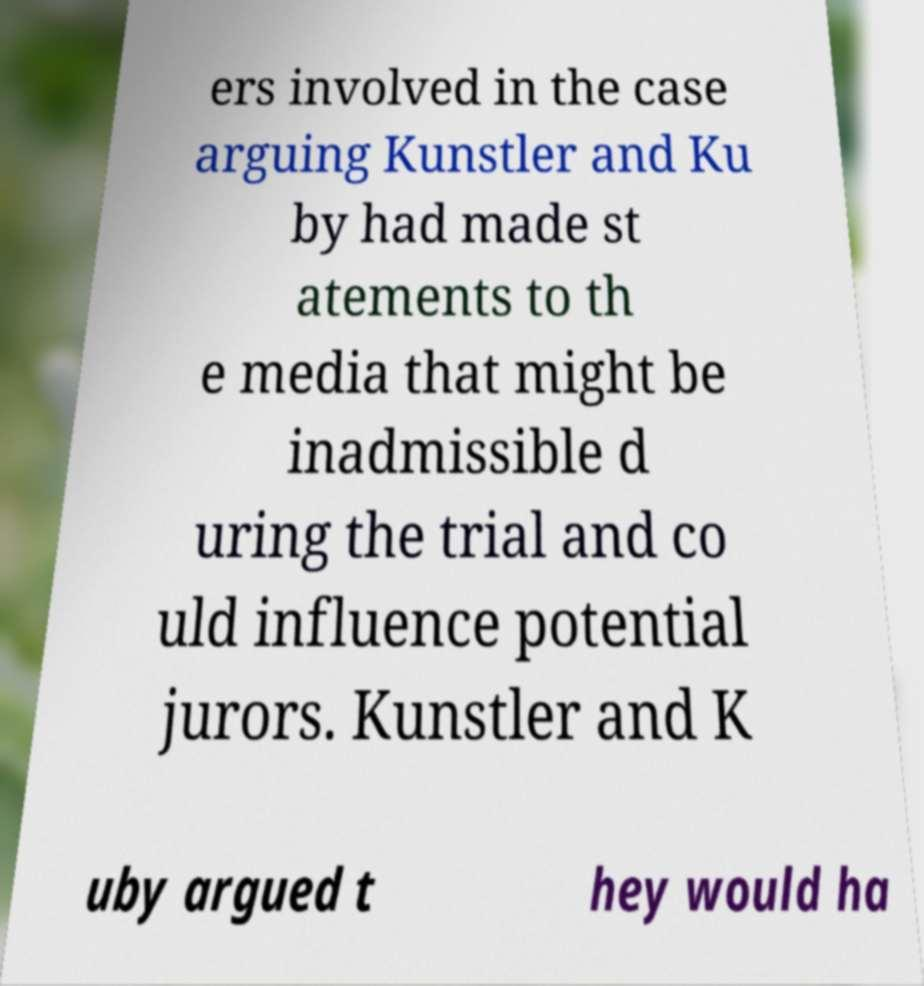Please identify and transcribe the text found in this image. ers involved in the case arguing Kunstler and Ku by had made st atements to th e media that might be inadmissible d uring the trial and co uld influence potential jurors. Kunstler and K uby argued t hey would ha 